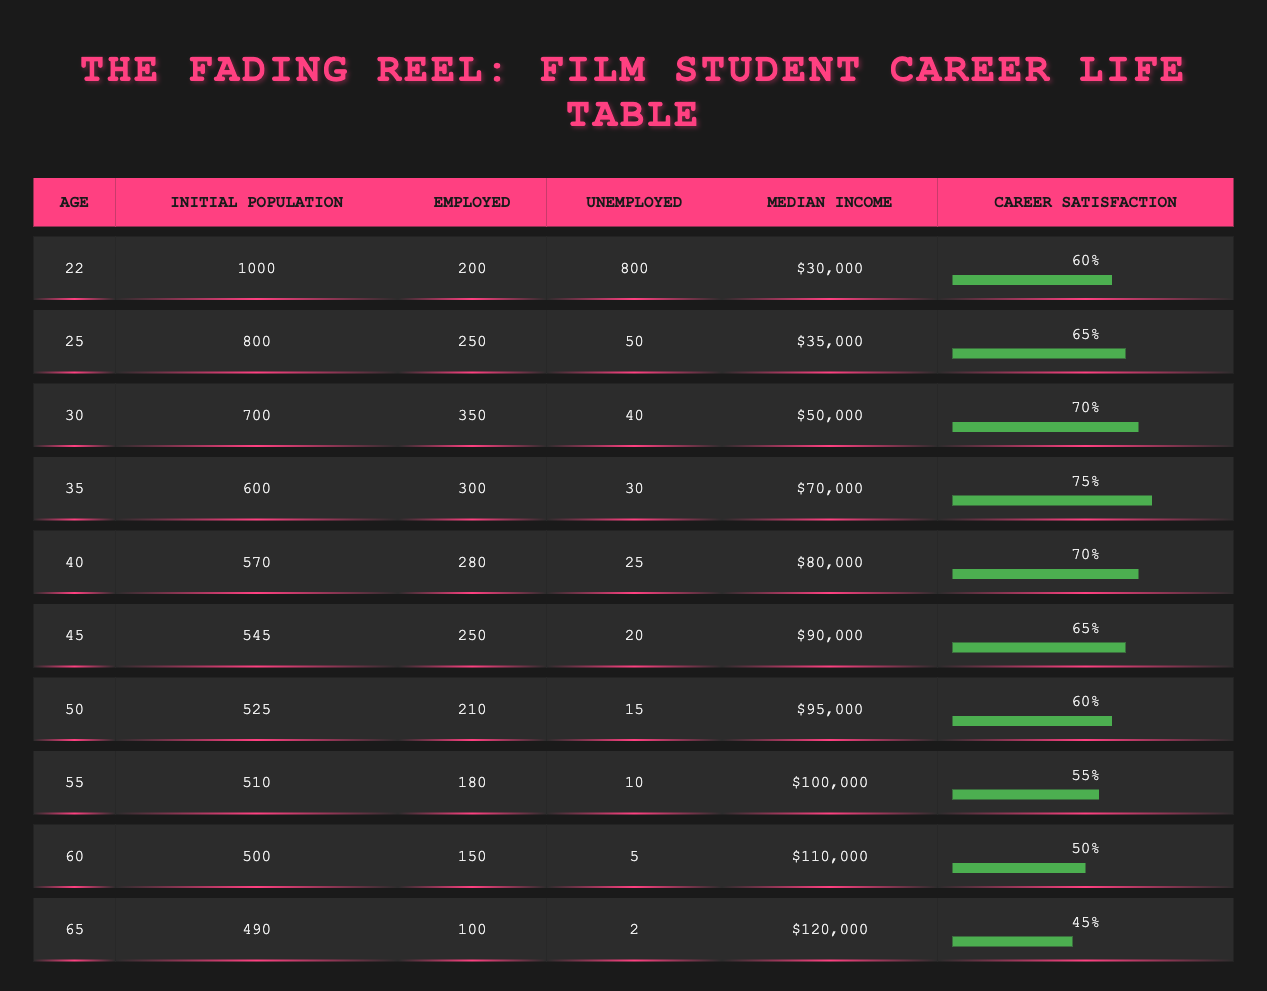What is the median income for film students at age 30? The median income for film students at age 30 is listed in the table as $50,000.
Answer: $50,000 At age 40, how many film students are unemployed? The table shows that at age 40, there are 25 unemployed film students.
Answer: 25 What is the total number of employed film students between the ages of 30 and 35? To find the total number of employed film students between these ages, we add the values from the table: 350 (age 30) + 300 (age 35) = 650.
Answer: 650 Is the career satisfaction for film students decreasing as they age? To determine this, we can compare the career satisfaction percentages from the table: 60% at age 22, increasing to 75% at age 35, then decreases to 45% at age 65. So, it does not consistently decrease; it increases until age 35 before decreasing.
Answer: No What is the average career satisfaction for film students aged 30 to 55? We will consider the career satisfaction percentages for ages 30 (70%), 35 (75%), 40 (70%), 45 (65%), 50 (60%), and 55 (55%). First, sum these values: 70 + 75 + 70 + 65 + 60 + 55 = 395. Then, divide by the number of data points (6): 395 / 6 = approximately 65.83.
Answer: 66 How many film students were employed at age 25? According to the table, the number of employed film students at age 25 is 250.
Answer: 250 What is the change in median income from age 22 to age 45? The median income at age 22 is $30,000 and at age 45 is $90,000. The change is calculated as $90,000 - $30,000 = $60,000.
Answer: $60,000 Is the employment percentage increasing overall from age 22 to age 65? To find the employment percentage, we divide the number of employed by the initial population for each age group. At age 22, it is 200/1000 = 20%, and at age 65, it is 100/490 = approximately 20.41%. Although the employment percentage at age 65 is slightly higher, there are fluctuations in earlier ages, so it does not strictly increase overall.
Answer: No 